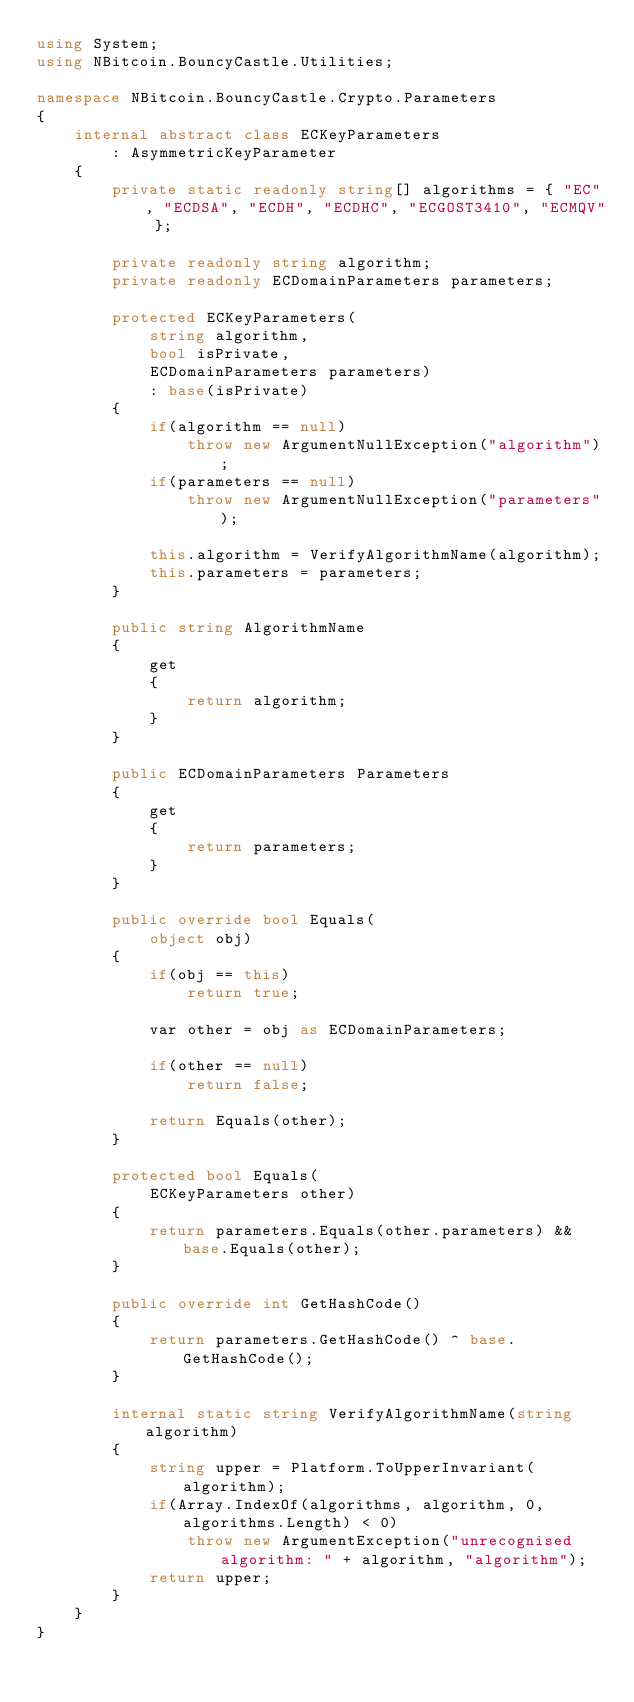<code> <loc_0><loc_0><loc_500><loc_500><_C#_>using System;
using NBitcoin.BouncyCastle.Utilities;

namespace NBitcoin.BouncyCastle.Crypto.Parameters
{
    internal abstract class ECKeyParameters
        : AsymmetricKeyParameter
    {
        private static readonly string[] algorithms = { "EC", "ECDSA", "ECDH", "ECDHC", "ECGOST3410", "ECMQV" };

        private readonly string algorithm;
        private readonly ECDomainParameters parameters;

        protected ECKeyParameters(
            string algorithm,
            bool isPrivate,
            ECDomainParameters parameters)
            : base(isPrivate)
        {
            if(algorithm == null)
                throw new ArgumentNullException("algorithm");
            if(parameters == null)
                throw new ArgumentNullException("parameters");

            this.algorithm = VerifyAlgorithmName(algorithm);
            this.parameters = parameters;
        }

        public string AlgorithmName
        {
            get
            {
                return algorithm;
            }
        }

        public ECDomainParameters Parameters
        {
            get
            {
                return parameters;
            }
        }

        public override bool Equals(
            object obj)
        {
            if(obj == this)
                return true;

            var other = obj as ECDomainParameters;

            if(other == null)
                return false;

            return Equals(other);
        }

        protected bool Equals(
            ECKeyParameters other)
        {
            return parameters.Equals(other.parameters) && base.Equals(other);
        }

        public override int GetHashCode()
        {
            return parameters.GetHashCode() ^ base.GetHashCode();
        }

        internal static string VerifyAlgorithmName(string algorithm)
        {
            string upper = Platform.ToUpperInvariant(algorithm);
            if(Array.IndexOf(algorithms, algorithm, 0, algorithms.Length) < 0)
                throw new ArgumentException("unrecognised algorithm: " + algorithm, "algorithm");
            return upper;
        }
    }
}
</code> 